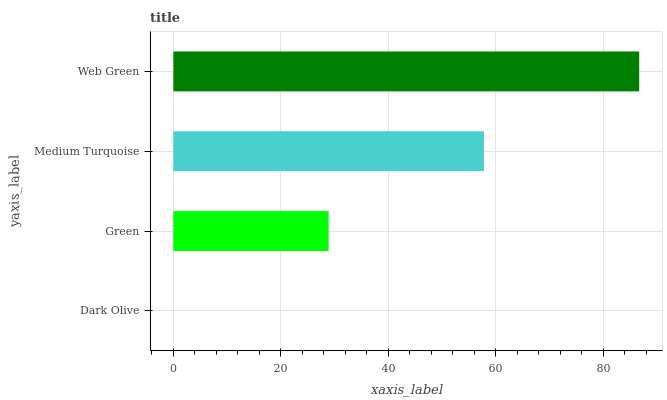Is Dark Olive the minimum?
Answer yes or no. Yes. Is Web Green the maximum?
Answer yes or no. Yes. Is Green the minimum?
Answer yes or no. No. Is Green the maximum?
Answer yes or no. No. Is Green greater than Dark Olive?
Answer yes or no. Yes. Is Dark Olive less than Green?
Answer yes or no. Yes. Is Dark Olive greater than Green?
Answer yes or no. No. Is Green less than Dark Olive?
Answer yes or no. No. Is Medium Turquoise the high median?
Answer yes or no. Yes. Is Green the low median?
Answer yes or no. Yes. Is Green the high median?
Answer yes or no. No. Is Medium Turquoise the low median?
Answer yes or no. No. 